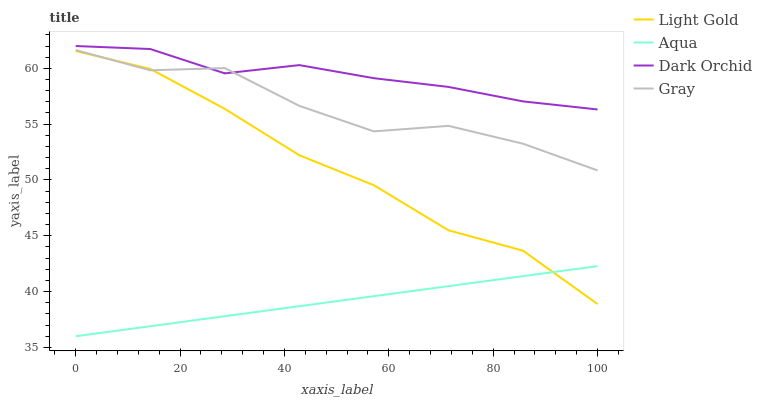Does Light Gold have the minimum area under the curve?
Answer yes or no. No. Does Light Gold have the maximum area under the curve?
Answer yes or no. No. Is Light Gold the smoothest?
Answer yes or no. No. Is Light Gold the roughest?
Answer yes or no. No. Does Light Gold have the lowest value?
Answer yes or no. No. Does Light Gold have the highest value?
Answer yes or no. No. Is Light Gold less than Dark Orchid?
Answer yes or no. Yes. Is Dark Orchid greater than Light Gold?
Answer yes or no. Yes. Does Light Gold intersect Dark Orchid?
Answer yes or no. No. 